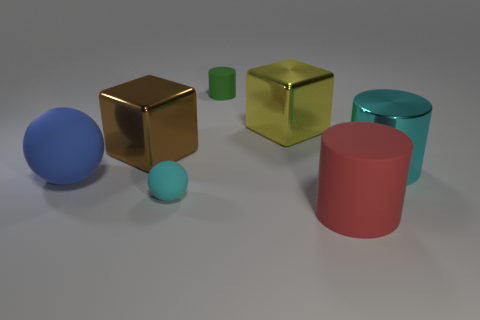Subtract all red matte cylinders. How many cylinders are left? 2 Add 2 green metal cylinders. How many objects exist? 9 Subtract all balls. How many objects are left? 5 Subtract 0 yellow cylinders. How many objects are left? 7 Subtract all gray cylinders. Subtract all red balls. How many cylinders are left? 3 Subtract all gray rubber blocks. Subtract all brown metal blocks. How many objects are left? 6 Add 2 big yellow blocks. How many big yellow blocks are left? 3 Add 4 green rubber cylinders. How many green rubber cylinders exist? 5 